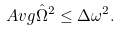Convert formula to latex. <formula><loc_0><loc_0><loc_500><loc_500>\ A v g { \hat { \Omega } ^ { 2 } } \leq \Delta \omega ^ { 2 } .</formula> 